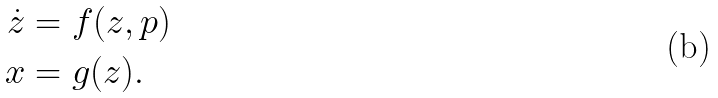<formula> <loc_0><loc_0><loc_500><loc_500>\dot { z } & = f ( z , p ) \\ x & = g ( z ) .</formula> 